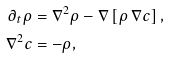<formula> <loc_0><loc_0><loc_500><loc_500>\partial _ { t } \rho & = \nabla ^ { 2 } \rho - \nabla \left [ \rho \, \nabla c \right ] , \\ \nabla ^ { 2 } c & = - \rho ,</formula> 